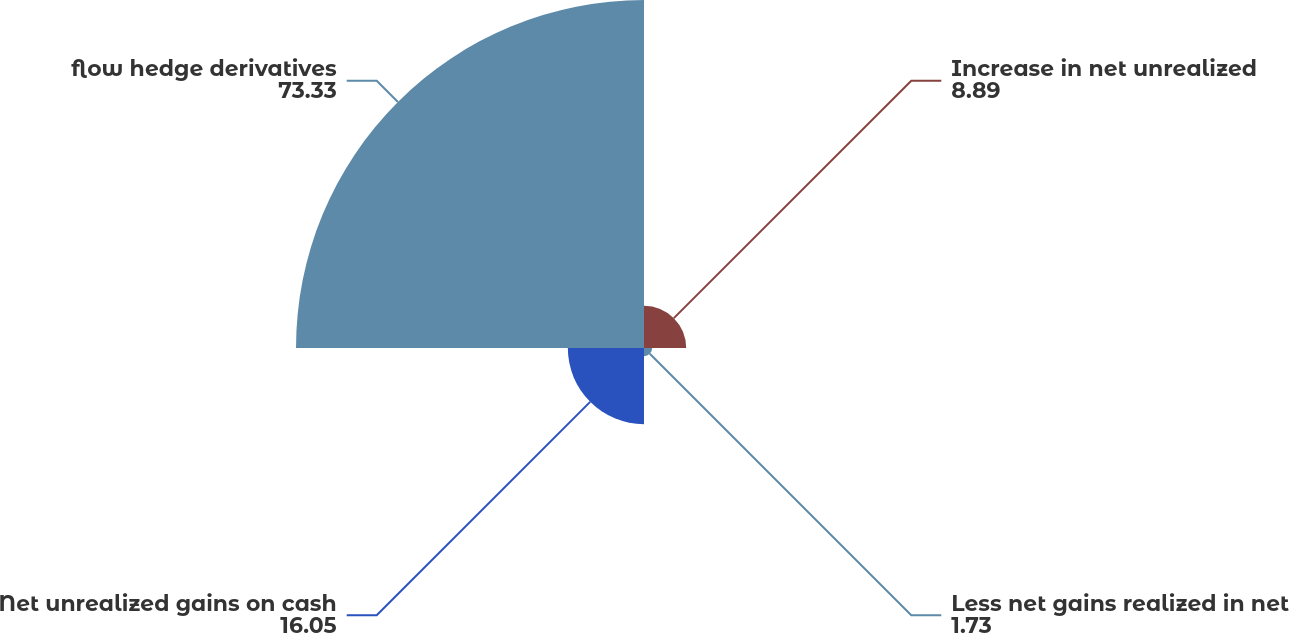Convert chart. <chart><loc_0><loc_0><loc_500><loc_500><pie_chart><fcel>Increase in net unrealized<fcel>Less net gains realized in net<fcel>Net unrealized gains on cash<fcel>flow hedge derivatives<nl><fcel>8.89%<fcel>1.73%<fcel>16.05%<fcel>73.33%<nl></chart> 